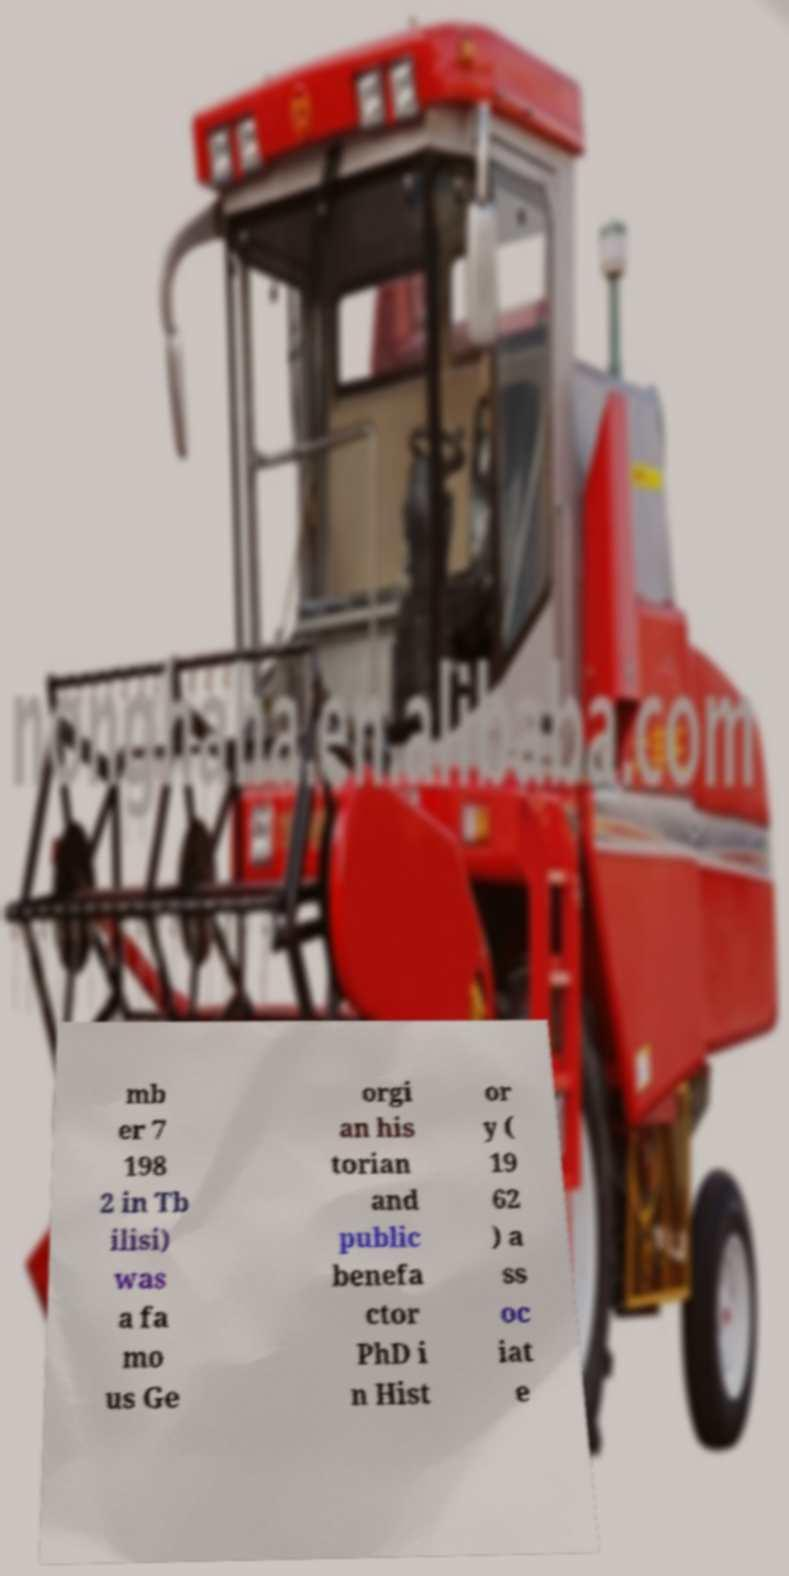Can you read and provide the text displayed in the image?This photo seems to have some interesting text. Can you extract and type it out for me? mb er 7 198 2 in Tb ilisi) was a fa mo us Ge orgi an his torian and public benefa ctor PhD i n Hist or y ( 19 62 ) a ss oc iat e 